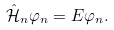Convert formula to latex. <formula><loc_0><loc_0><loc_500><loc_500>\hat { \mathcal { H } } _ { n } \varphi _ { n } = E \varphi _ { n } .</formula> 